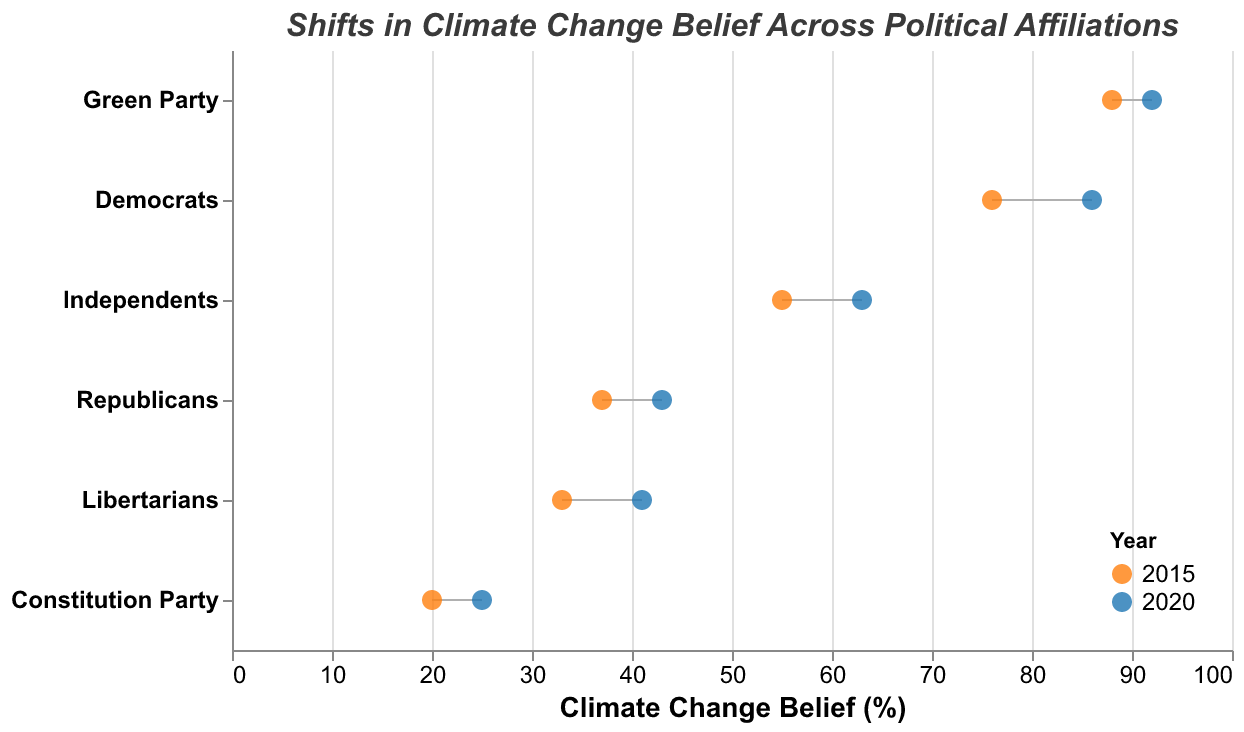What's the title of the figure? The title is displayed at the top of the figure.
Answer: Shifts in Climate Change Belief Across Political Affiliations Which political affiliation had the lowest belief in climate change in 2015? Look at the data points for 2015; the belief percentages range from 20% to 88%. The lowest is 20% for the Constitution Party.
Answer: Constitution Party How much did the Democrats' belief in climate change increase from 2015 to 2020? Subtract the 2015 belief percentage from the 2020 belief percentage for Democrats (86% - 76%).
Answer: 10% Between 2015 and 2020, which political affiliation showed the smallest increase in belief? Calculate the difference for each affiliation. Green Party: 92-88=4, Constitution Party: 25-20=5, so the smallest increase is 4% for the Green Party.
Answer: Green Party Comparing Independents and Libertarians, which group had a higher belief in climate change in 2015? Check the belief percentages for 2015 for both groups. Independents: 55%, Libertarians: 33%.
Answer: Independents What is the belief percentage in climate change for Republicans in 2020? Look at the data points specifically for Republicans in 2020.
Answer: 43% Which political affiliations had a higher belief in climate change than Independents in 2020? Compare the 2020 values for Independents (63%) with other affiliations. Democrats (86%), Green Party (92%) are higher.
Answer: Democrats, Green Party What is the range of belief in climate change among all political affiliations in 2020? Find the minimum and maximum percentages in 2020. Minimum: Constitution Party (25%), Maximum: Green Party (92%). Range: 92% - 25% = 67%.
Answer: 67% Which political affiliation showed a belief percentage closest to 50% in 2015? Check the 2015 belief percentages and see which is closest to 50%. Independents had 55%, which is closest.
Answer: Independents Is the change in climate change belief from 2015 to 2020 for Democrats greater than the change for Republicans? Calculate the changes: Democrats (10%) and Republicans (6%), compare the two changes.
Answer: Yes 